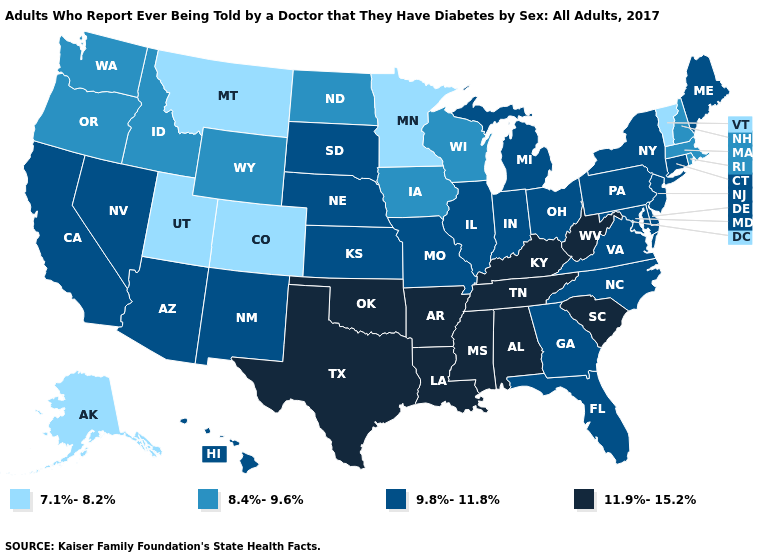Does the first symbol in the legend represent the smallest category?
Be succinct. Yes. What is the value of Tennessee?
Keep it brief. 11.9%-15.2%. Which states have the lowest value in the South?
Be succinct. Delaware, Florida, Georgia, Maryland, North Carolina, Virginia. What is the lowest value in the Northeast?
Write a very short answer. 7.1%-8.2%. Name the states that have a value in the range 9.8%-11.8%?
Write a very short answer. Arizona, California, Connecticut, Delaware, Florida, Georgia, Hawaii, Illinois, Indiana, Kansas, Maine, Maryland, Michigan, Missouri, Nebraska, Nevada, New Jersey, New Mexico, New York, North Carolina, Ohio, Pennsylvania, South Dakota, Virginia. Among the states that border Kansas , which have the highest value?
Quick response, please. Oklahoma. What is the lowest value in states that border Wisconsin?
Be succinct. 7.1%-8.2%. Is the legend a continuous bar?
Keep it brief. No. What is the highest value in the South ?
Give a very brief answer. 11.9%-15.2%. Among the states that border Georgia , which have the lowest value?
Be succinct. Florida, North Carolina. What is the value of Oklahoma?
Write a very short answer. 11.9%-15.2%. Name the states that have a value in the range 7.1%-8.2%?
Answer briefly. Alaska, Colorado, Minnesota, Montana, Utah, Vermont. Name the states that have a value in the range 11.9%-15.2%?
Write a very short answer. Alabama, Arkansas, Kentucky, Louisiana, Mississippi, Oklahoma, South Carolina, Tennessee, Texas, West Virginia. What is the value of Georgia?
Write a very short answer. 9.8%-11.8%. Among the states that border South Carolina , which have the highest value?
Give a very brief answer. Georgia, North Carolina. 